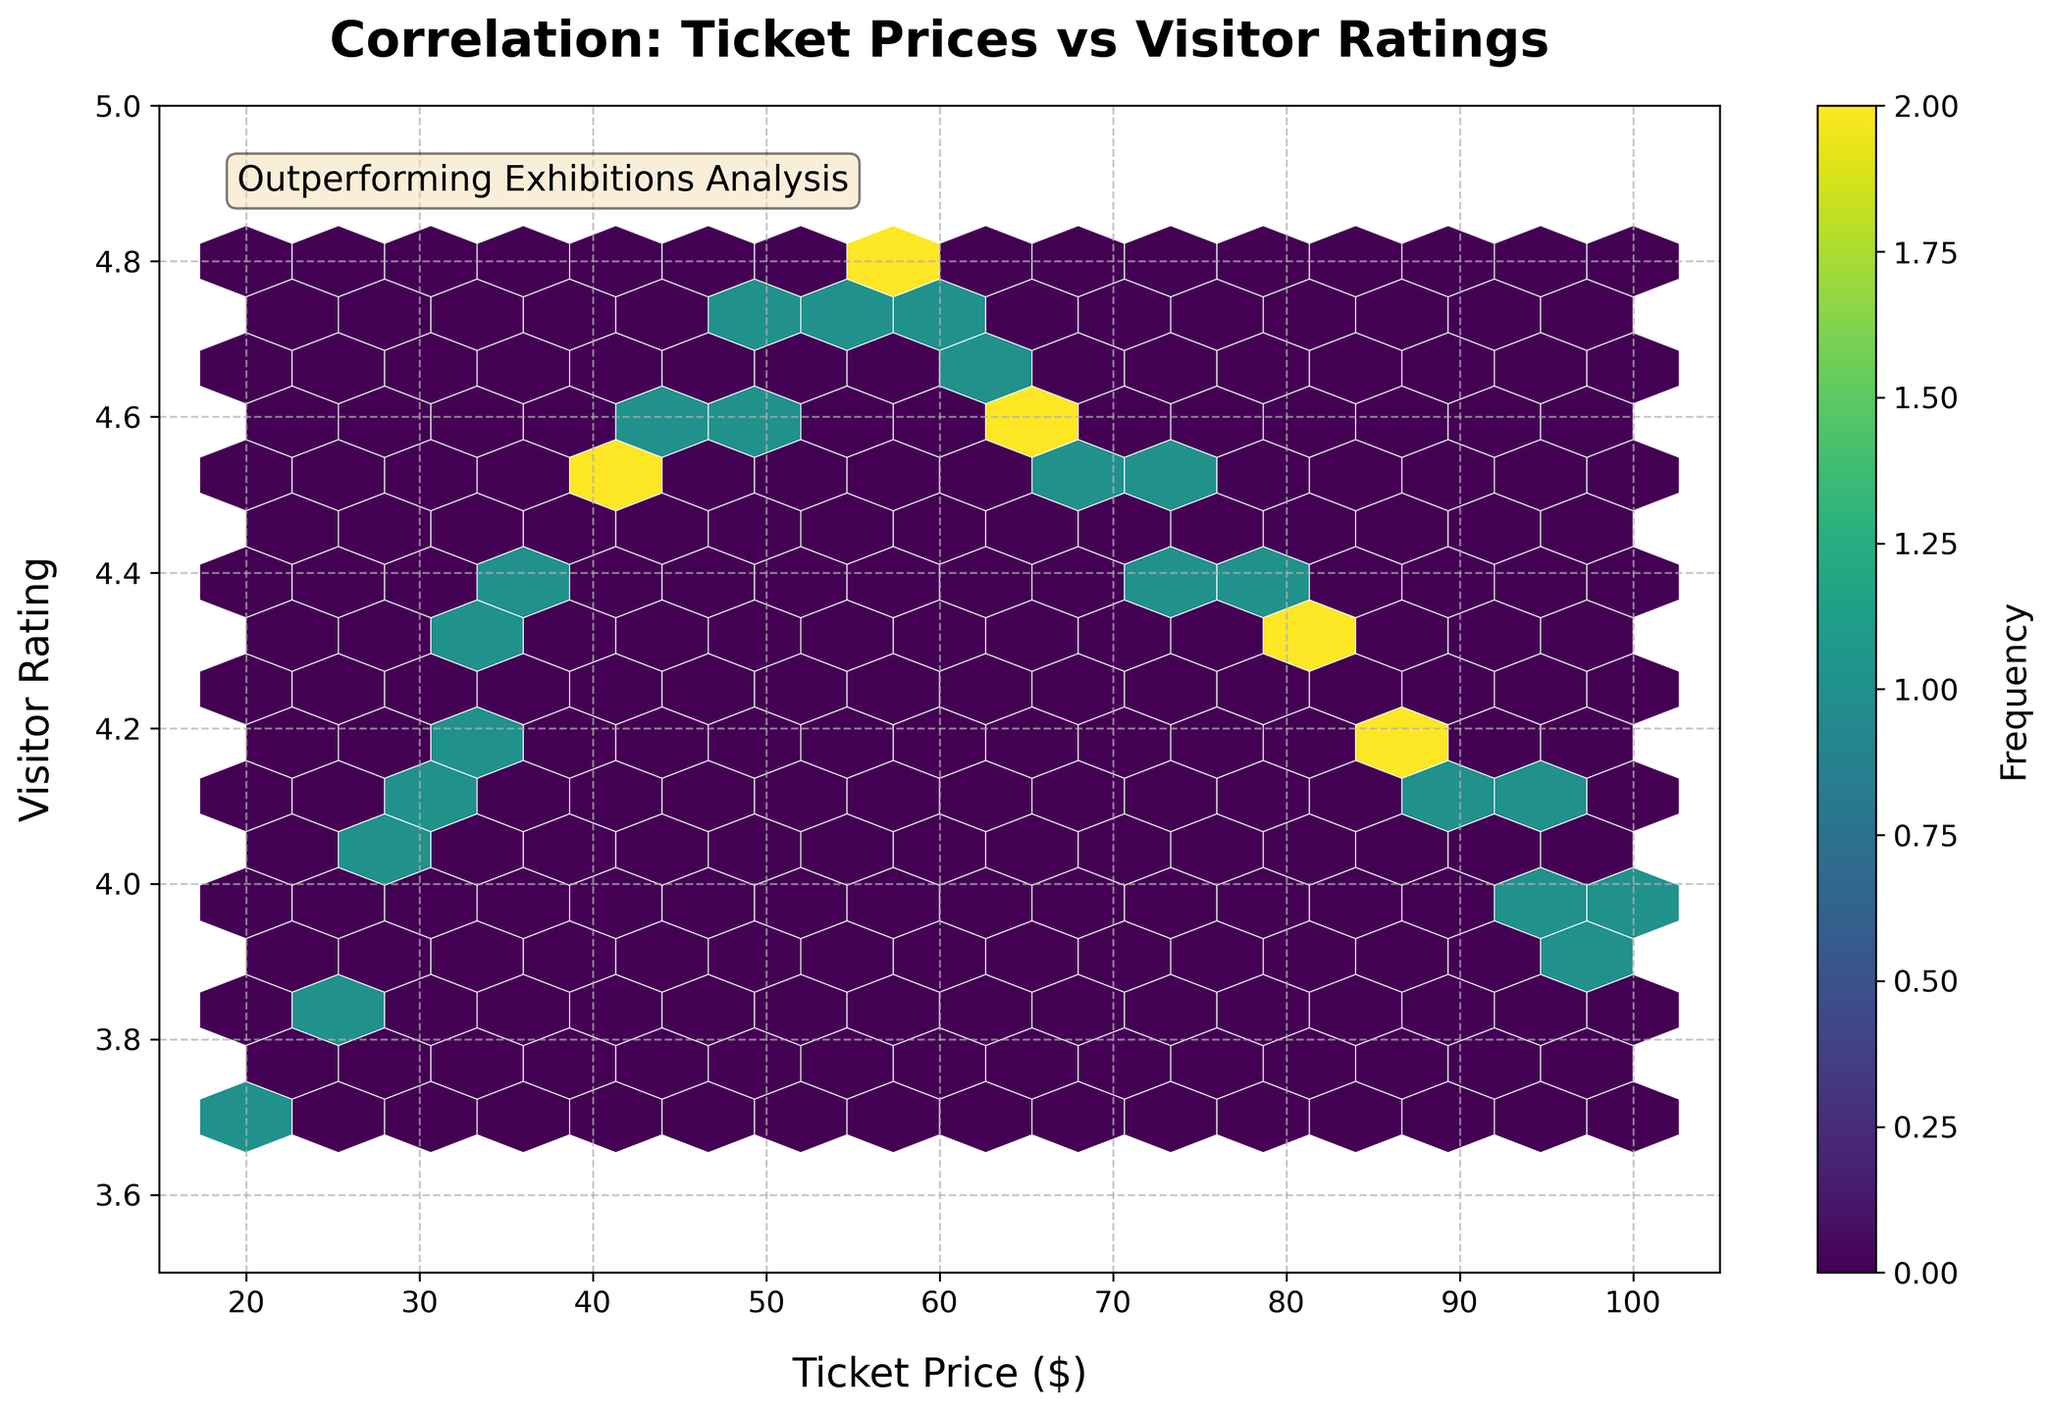What's the title of the hexbin plot? The title of the plot is positioned above the hexbin plot in large, bold font. The title states the main focus of the plot, which is the relationship between ticket prices and visitor ratings for special exhibitions.
Answer: Correlation: Ticket Prices vs Visitor Ratings What are the ranges of the x and y axes? On the x-axis, which represents ticket price, the range is indicated from 15 to 105. The y-axis, which represents visitor rating, has a range from 3.5 to 5.0.
Answer: x-axis: 15 to 105, y-axis: 3.5 to 5.0 What does the color indicate in the hexbin plot? The color in the hexbin plot represents the frequency of data points within each hexagon. The color bar on the right side of the plot shows the mapping from color to frequency, with darker colors indicating higher frequencies.
Answer: Frequency of data points Where are the highest frequency hexagons located? The highest frequency hexagons are identified by the darkest colors. By examining the plot, these hexagons are located in the middle range of ticket prices (approximately 50-65) and higher visitor ratings (approximately 4.7).
Answer: Ticket price: 50-65, Visitor rating: 4.7 Is there a trend visible in the hexbin plot between ticket prices and visitor ratings? By closely observing the spread and colors of the hexagons, a trend is visible showing that as ticket prices increase, visitor ratings also increase up to a certain point (around $55-$60), after which ratings start to slightly decrease.
Answer: Yes, an increasing then decreasing trend What's the average visitor rating for the ticket prices in the range of 40 to 60 dollars? First, identify the hexagons in the range of 40 to 60 dollars on the x-axis. Then, check the average ratings for these ticket prices. These points fall around a visitor rating of approximately 4.6 to 4.7 on average.
Answer: Approximately 4.65 Comparing ticket prices at $25 and $95, which one has a higher visitor rating? Locate the hexagons at ticket prices $25 and $95. From the y-axis values, it is clear that the hexagon at $25 has a visitor rating of around 3.8, while $95 has a rating of around 4.0.
Answer: $95 What can you infer from the trend of visitor ratings for ticket prices above $60? The plot shows that as ticket prices increase beyond $60, there is a slight decline in visitor ratings, indicating that higher ticket prices may not necessarily correlate with higher visitor satisfaction beyond this point.
Answer: Slight decline in ratings What is the hexbin grid size used in this plot? The hexbin grid size represents the resolution or number of hexagons used to aggregate the data points. This can be inferred from the proximity and number of hexagons in the plot. The grid size used here is 15 as indicated in the code.
Answer: 15 Why might the curator of the museum be interested in this hexbin plot? This hexbin plot visually demonstrates the correlation between ticket prices and visitor satisfaction, aiding the curator in pricing decisions to maximize both revenue and visitor satisfaction. Optimal ticket pricing strategies can be derived from understanding these trends.
Answer: To make pricing decisions based on trends 